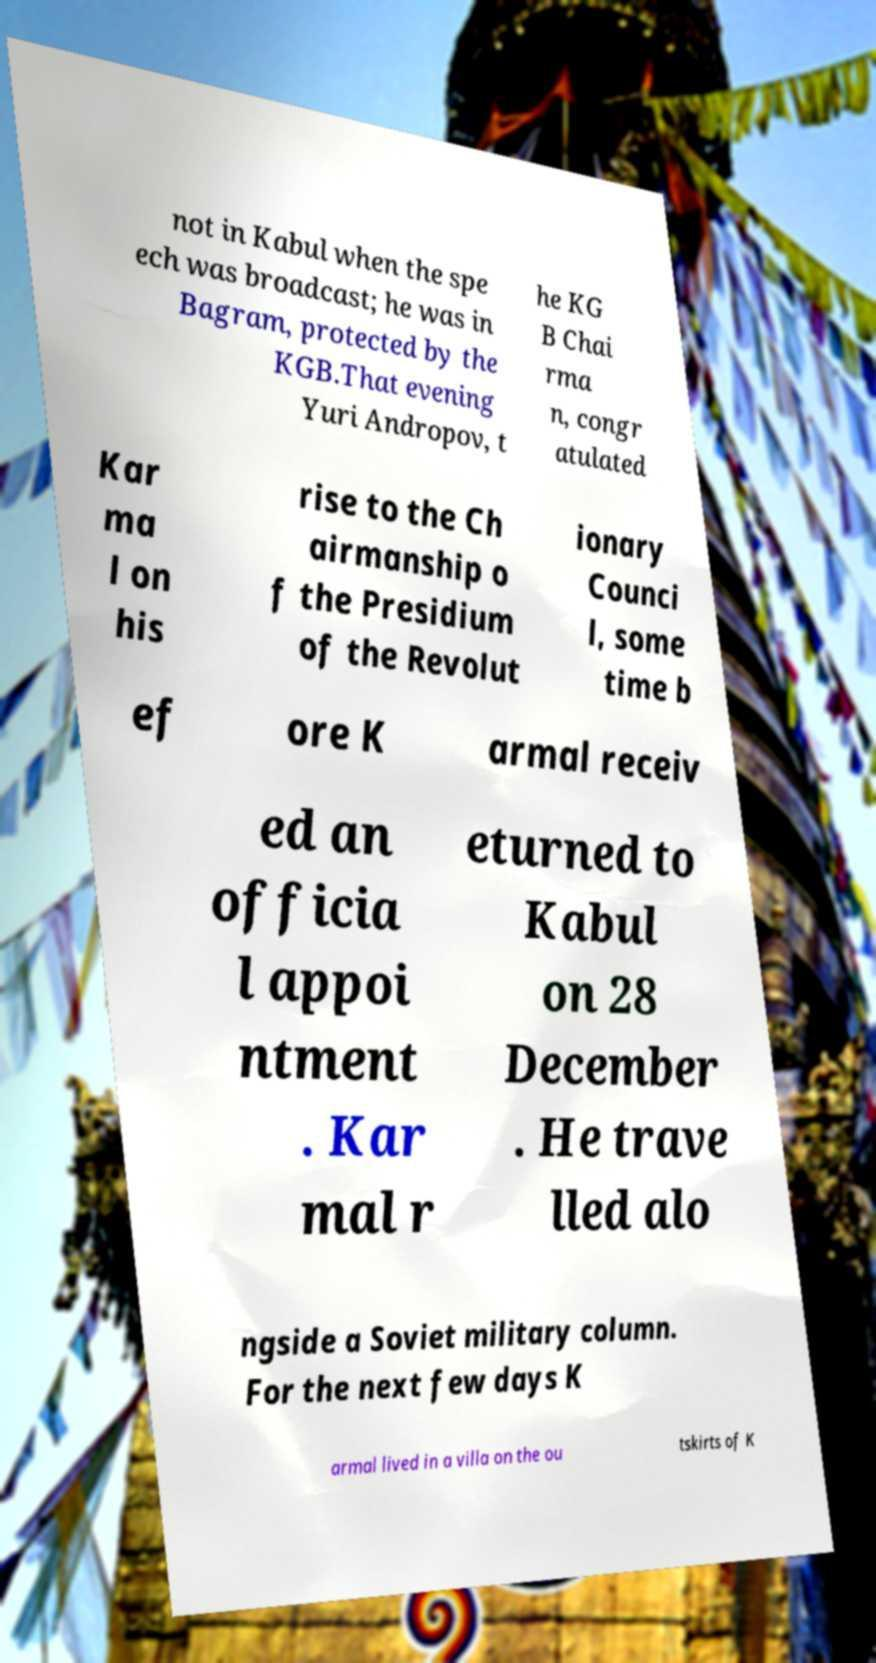There's text embedded in this image that I need extracted. Can you transcribe it verbatim? not in Kabul when the spe ech was broadcast; he was in Bagram, protected by the KGB.That evening Yuri Andropov, t he KG B Chai rma n, congr atulated Kar ma l on his rise to the Ch airmanship o f the Presidium of the Revolut ionary Counci l, some time b ef ore K armal receiv ed an officia l appoi ntment . Kar mal r eturned to Kabul on 28 December . He trave lled alo ngside a Soviet military column. For the next few days K armal lived in a villa on the ou tskirts of K 